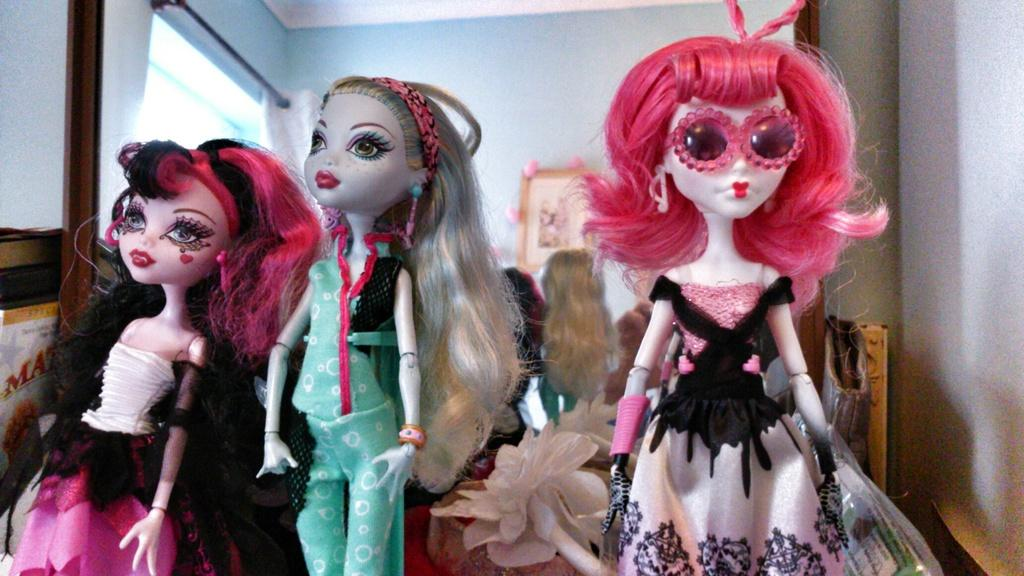What objects are present in the image? There are dolls in the image. What can be seen in the background of the image? There is a wall in the background of the image. What is placed on the wall? There is a frame placed on the wall. What is on the left side of the image? There is a curtain on the left side of the image. What is visible through the curtain? There is a window visible through the curtain. What type of roof can be seen on the dollhouse in the image? There is no dollhouse present in the image, so it is not possible to determine the type of roof. 